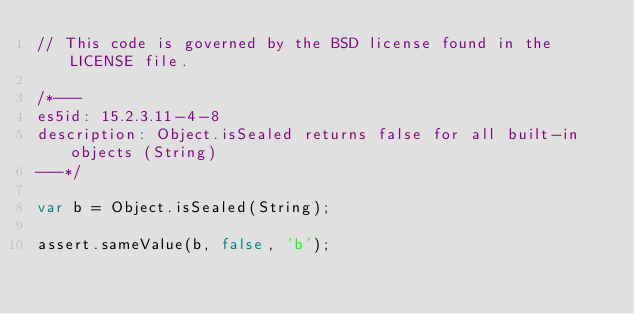<code> <loc_0><loc_0><loc_500><loc_500><_JavaScript_>// This code is governed by the BSD license found in the LICENSE file.

/*---
es5id: 15.2.3.11-4-8
description: Object.isSealed returns false for all built-in objects (String)
---*/

var b = Object.isSealed(String);

assert.sameValue(b, false, 'b');
</code> 